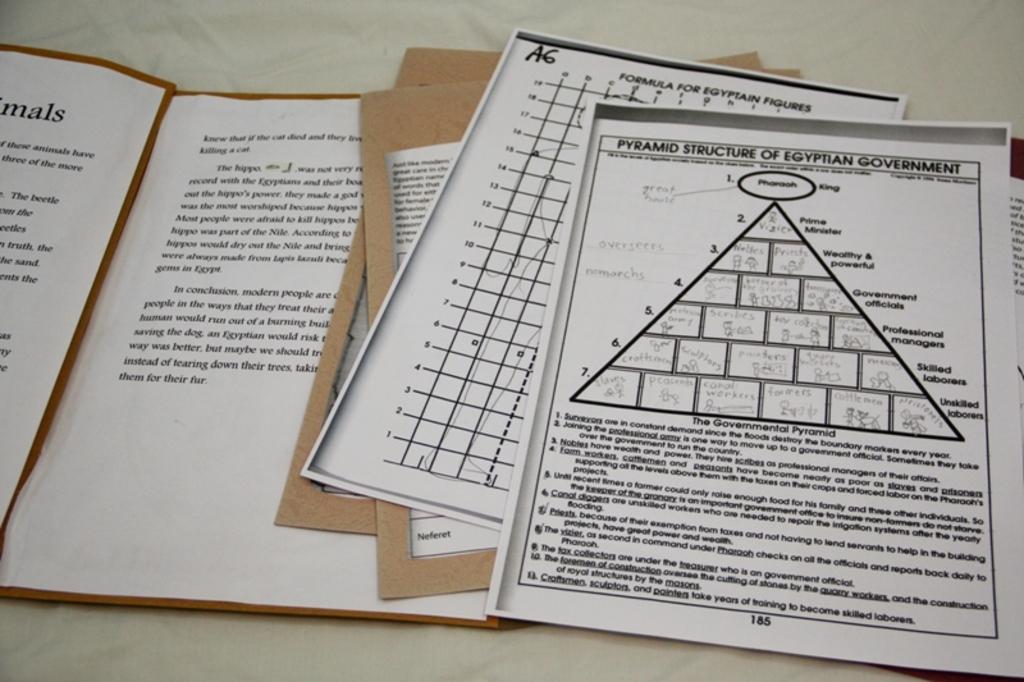Is the king at the top of the pyramid?
Your response must be concise. Yes. 